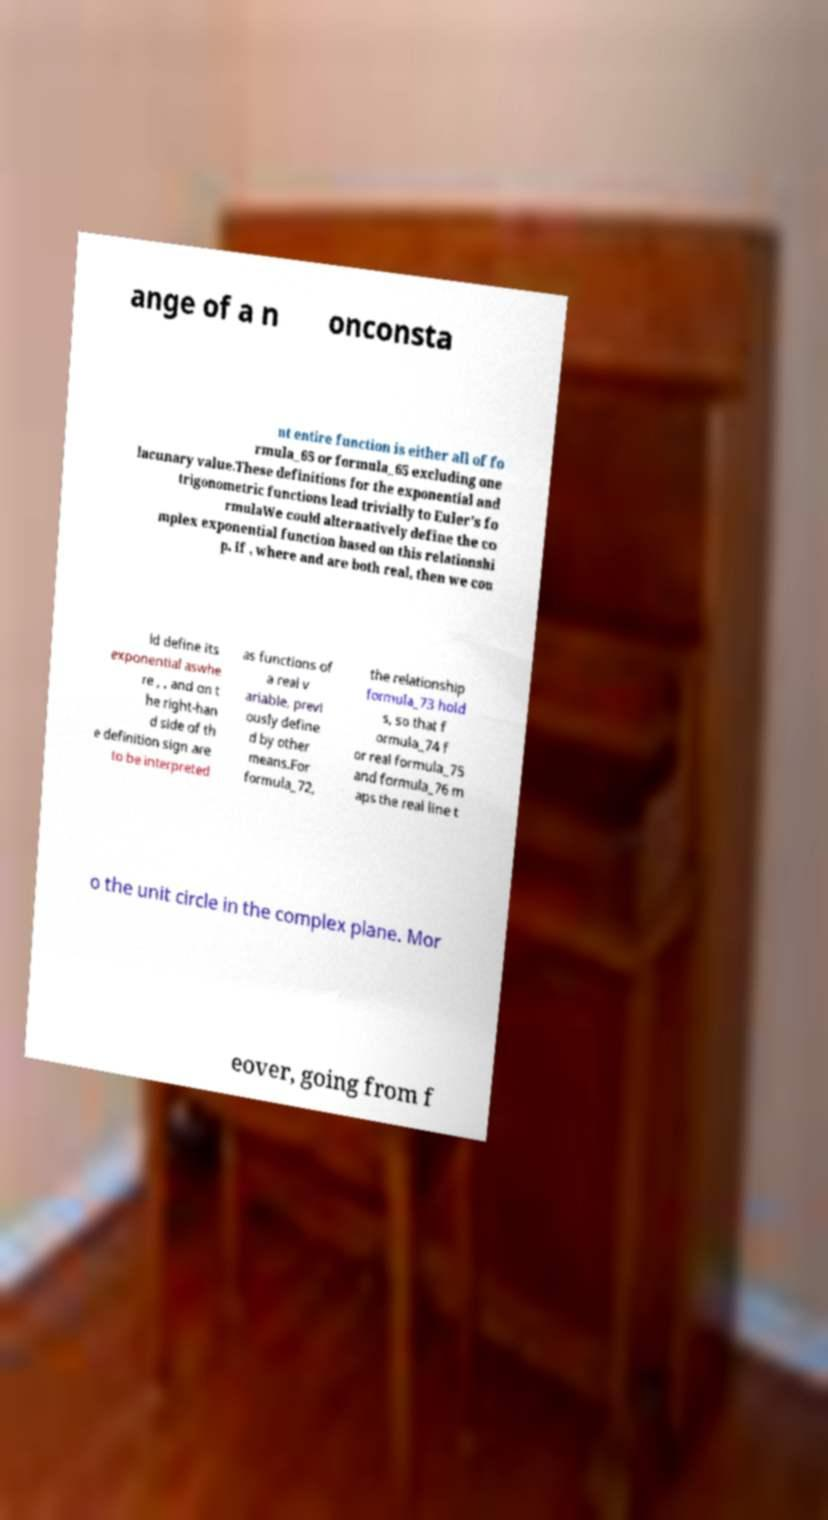There's text embedded in this image that I need extracted. Can you transcribe it verbatim? ange of a n onconsta nt entire function is either all of fo rmula_65 or formula_65 excluding one lacunary value.These definitions for the exponential and trigonometric functions lead trivially to Euler's fo rmulaWe could alternatively define the co mplex exponential function based on this relationshi p. If , where and are both real, then we cou ld define its exponential aswhe re , , and on t he right-han d side of th e definition sign are to be interpreted as functions of a real v ariable, previ ously define d by other means.For formula_72, the relationship formula_73 hold s, so that f ormula_74 f or real formula_75 and formula_76 m aps the real line t o the unit circle in the complex plane. Mor eover, going from f 